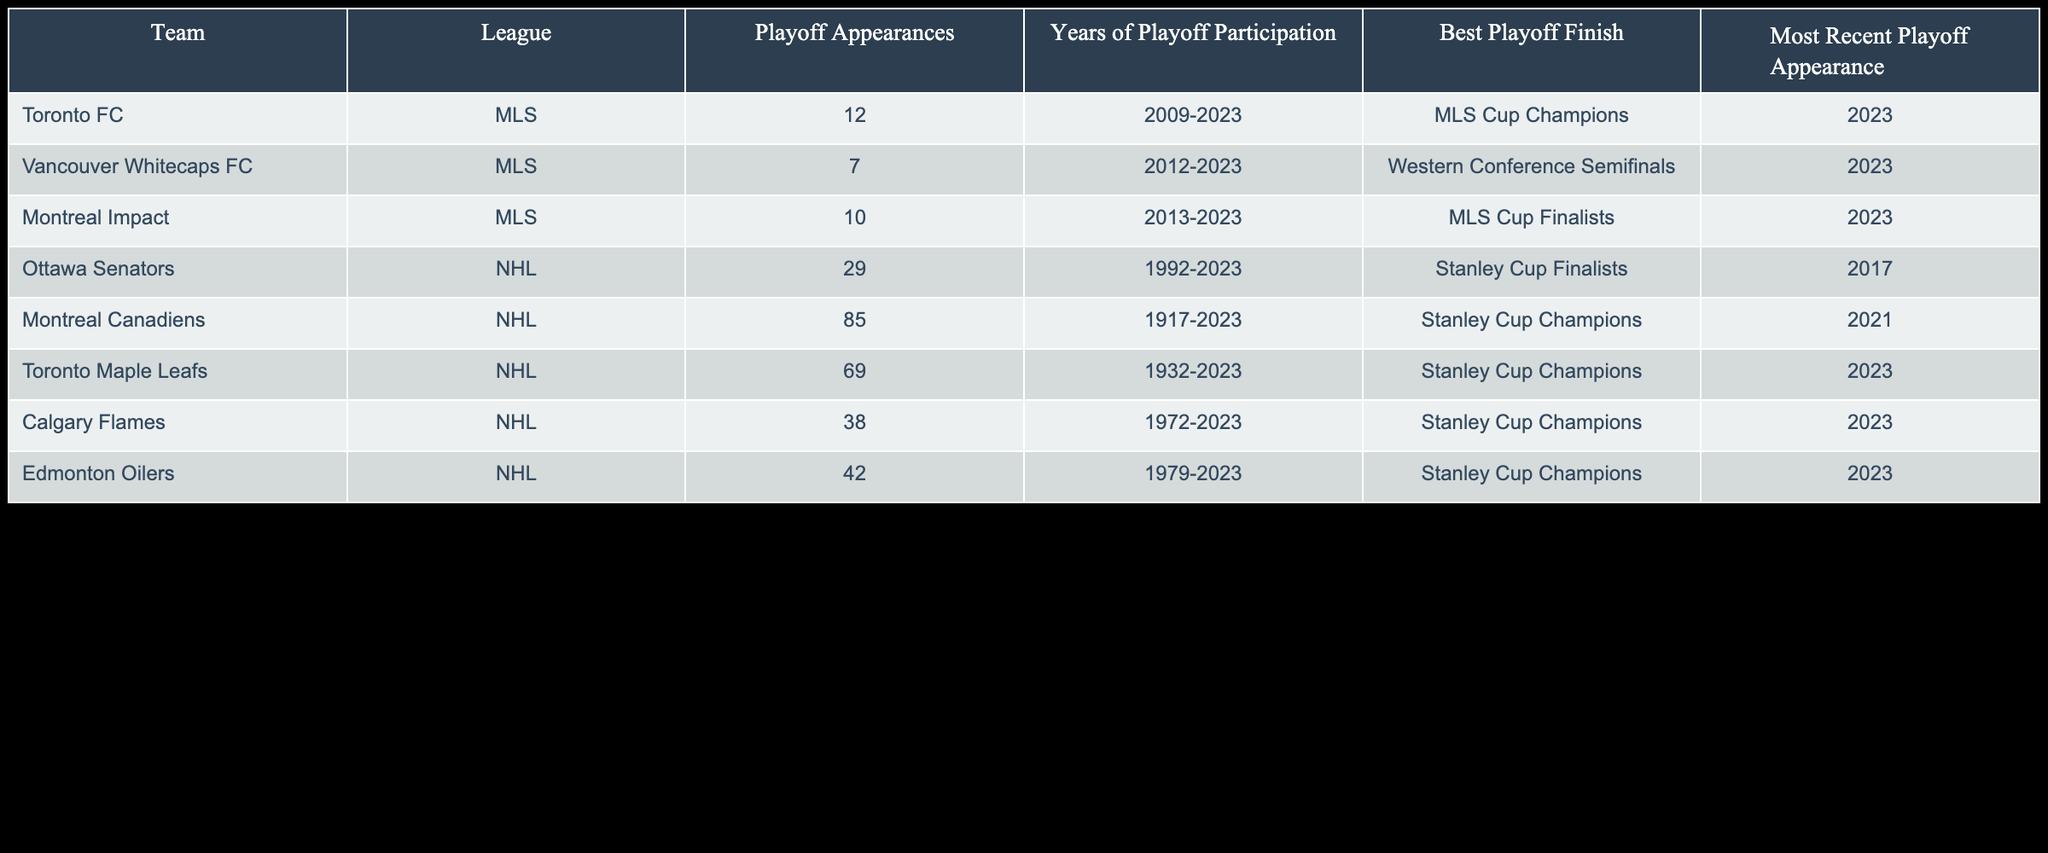What is the best playoff finish for Toronto FC? The best playoff finish for Toronto FC is listed in the table under "Best Playoff Finish", which states "MLS Cup Champions".
Answer: MLS Cup Champions How many playoff appearances do the Vancouver Whitecaps FC have? The number of playoff appearances for Vancouver Whitecaps FC can be found in the "Playoff Appearances" column, which shows a total of 7 appearances.
Answer: 7 Which team has the most playoff appearances in the NHL? To find the team with the most playoff appearances, we can compare the "Playoff Appearances" for all teams in the NHL. The Montreal Canadiens have 85 playoff appearances, which is the highest among the listed teams.
Answer: Montreal Canadiens Is it true that all teams listed have made playoff appearances in the past two years? To confirm this, we will check the "Most Recent Playoff Appearance" for each team. All teams have either 2023 or 2021 as their most recent playoff appearances, confirming they all participated in playoffs in the last two years.
Answer: Yes What is the average number of playoff appearances for the Canadian teams in the NHL? The playoff appearances for the NHL teams are 29 (Ottawa Senators), 85 (Montreal Canadiens), 69 (Toronto Maple Leafs), 38 (Calgary Flames), and 42 (Edmonton Oilers). The total is 263, and there are 5 teams, so the average is 263 divided by 5, which equals 52.6.
Answer: 52.6 Which Canadian soccer team made it to the MLS Cup final? From the "Best Playoff Finish" column, the Montreal Impact is identified as having made it to the MLS Cup final.
Answer: Montreal Impact How many Stanley Cup Champions have played since the year 2000? We look for teams listed under "Best Playoff Finish" with the status "Stanley Cup Champions" and check their years of participation. Toronto Maple Leafs (2023), Calgary Flames (2023), Edmonton Oilers (2023), and Montreal Canadiens (2021). Counting these gives us 4 champions since 2000.
Answer: 4 Which team has the fewest playoff appearances in the MLS? Reviewing the "Playoff Appearances" for the Canadian teams in the MLS, the Vancouver Whitecaps FC has the fewest with a total of 7 playoff appearances compared to the others.
Answer: Vancouver Whitecaps FC How many years did the Ottawa Senators participate in the playoffs? The "Years of Playoff Participation" for the Ottawa Senators is indicated in the table as 1992-2023, which confirms participation over a span of 31 years.
Answer: 31 years 